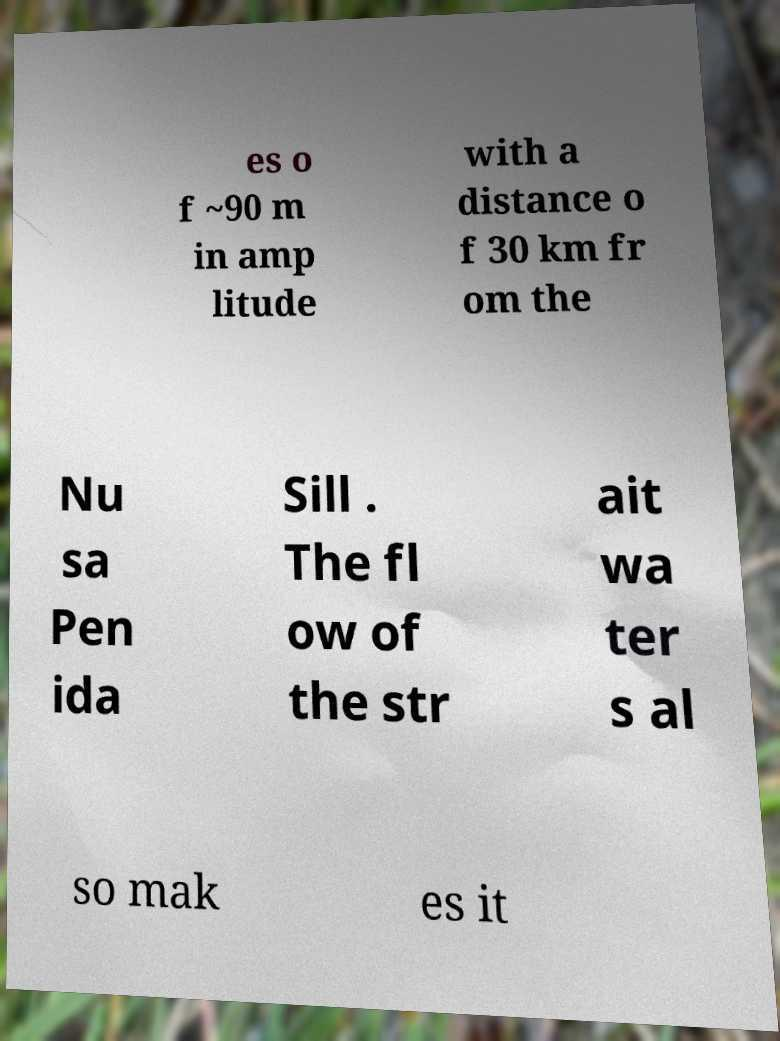I need the written content from this picture converted into text. Can you do that? es o f ~90 m in amp litude with a distance o f 30 km fr om the Nu sa Pen ida Sill . The fl ow of the str ait wa ter s al so mak es it 